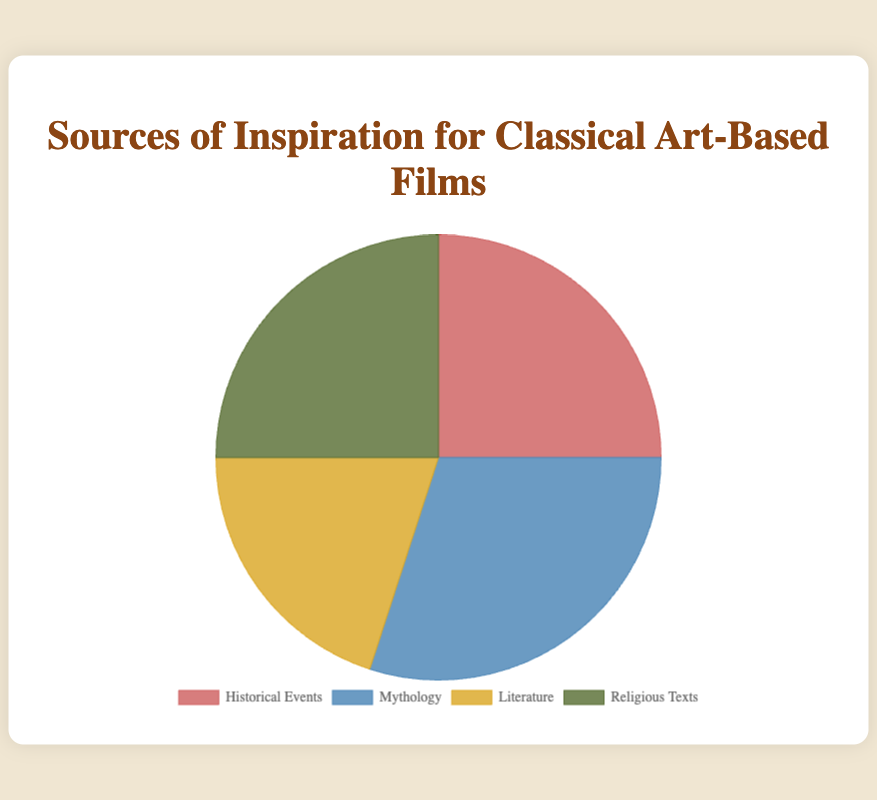What is the most common source of inspiration for classical art-based films? By observing the pie chart, Mythology has the largest sector, which means it is the most common source. The other sources, Historical Events and Religious Texts, share a slightly smaller portion, and Literature has the smallest.
Answer: Mythology Which two sources share the same percentage of inspiration? The pie chart shows that both Historical Events and Religious Texts each make up 25% of the inspiration sources.
Answer: Historical Events and Religious Texts How much larger is the percentage of Mythology than Literature? The pie chart indicates that Mythology makes up 30% of the sources, while Literature makes up 20%. The difference between these percentages is calculated as 30% - 20% = 10%.
Answer: 10% What is the combined percentage of Historical Events and Religious Texts? By adding the percentages shown for Historical Events (25%) and Religious Texts (25%), the combined total is 25% + 25% = 50%.
Answer: 50% Which source has a golden color? Based on the color descriptions provided, Literature is represented in a golden color.
Answer: Literature 